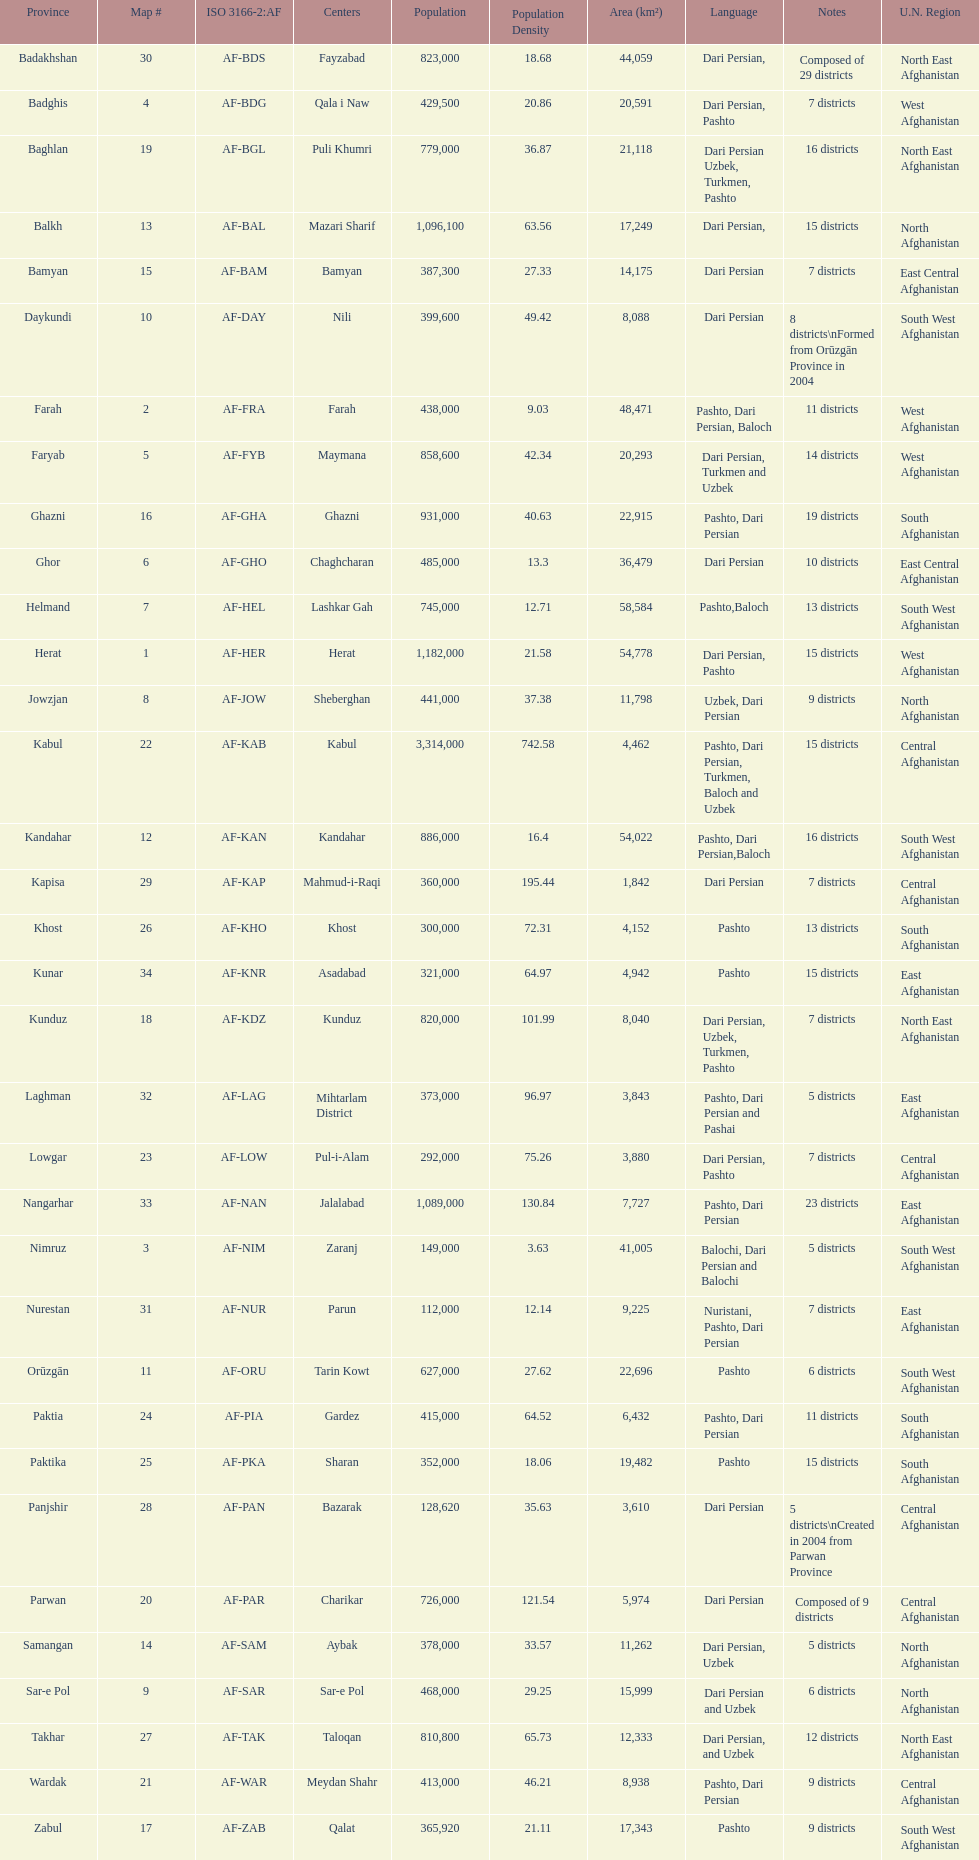Herat has a population of 1,182,000, can you list their languages Dari Persian, Pashto. 